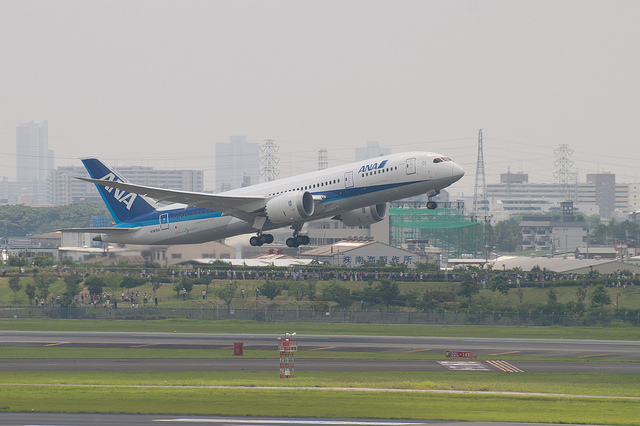Please extract the text content from this image. ANA ANA 